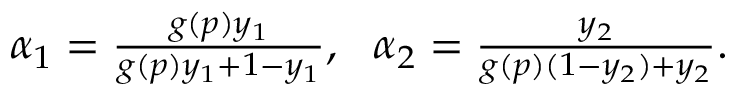Convert formula to latex. <formula><loc_0><loc_0><loc_500><loc_500>\begin{array} { r } { \alpha _ { 1 } = \frac { g ( p ) y _ { 1 } } { g ( p ) y _ { 1 } + 1 - y _ { 1 } } , \quad a l p h a _ { 2 } = \frac { y _ { 2 } } { g ( p ) ( 1 - y _ { 2 } ) + y _ { 2 } } . } \end{array}</formula> 